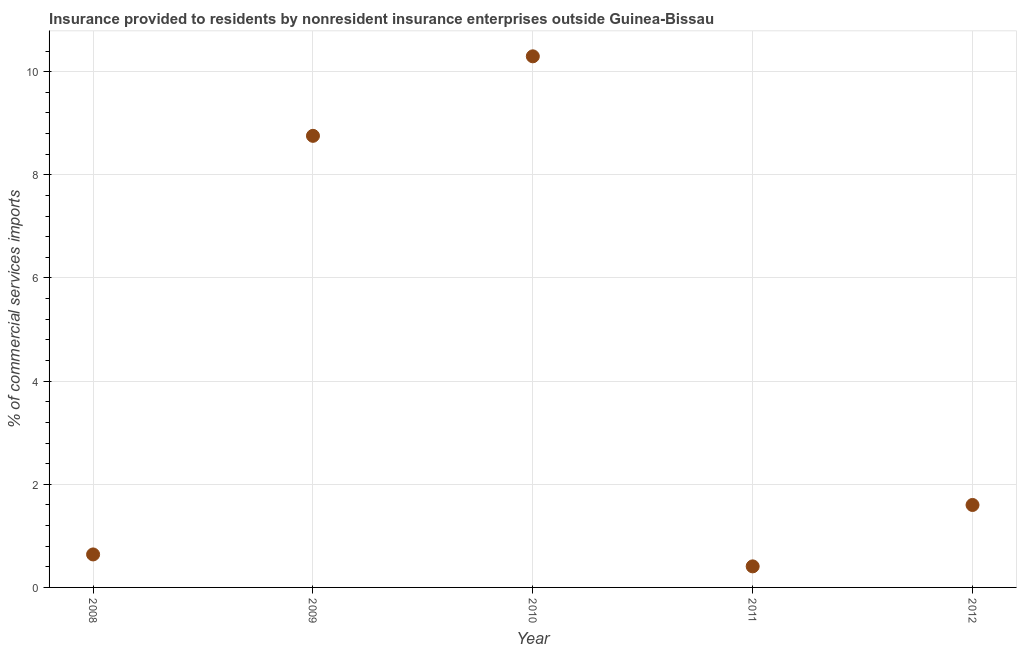What is the insurance provided by non-residents in 2010?
Offer a very short reply. 10.3. Across all years, what is the maximum insurance provided by non-residents?
Offer a terse response. 10.3. Across all years, what is the minimum insurance provided by non-residents?
Keep it short and to the point. 0.41. What is the sum of the insurance provided by non-residents?
Give a very brief answer. 21.7. What is the difference between the insurance provided by non-residents in 2008 and 2009?
Provide a succinct answer. -8.12. What is the average insurance provided by non-residents per year?
Provide a succinct answer. 4.34. What is the median insurance provided by non-residents?
Your answer should be very brief. 1.6. In how many years, is the insurance provided by non-residents greater than 6.4 %?
Your response must be concise. 2. What is the ratio of the insurance provided by non-residents in 2008 to that in 2010?
Keep it short and to the point. 0.06. Is the difference between the insurance provided by non-residents in 2008 and 2010 greater than the difference between any two years?
Keep it short and to the point. No. What is the difference between the highest and the second highest insurance provided by non-residents?
Your response must be concise. 1.54. Is the sum of the insurance provided by non-residents in 2008 and 2010 greater than the maximum insurance provided by non-residents across all years?
Provide a short and direct response. Yes. What is the difference between the highest and the lowest insurance provided by non-residents?
Give a very brief answer. 9.89. Are the values on the major ticks of Y-axis written in scientific E-notation?
Give a very brief answer. No. Does the graph contain grids?
Make the answer very short. Yes. What is the title of the graph?
Give a very brief answer. Insurance provided to residents by nonresident insurance enterprises outside Guinea-Bissau. What is the label or title of the Y-axis?
Make the answer very short. % of commercial services imports. What is the % of commercial services imports in 2008?
Offer a very short reply. 0.64. What is the % of commercial services imports in 2009?
Make the answer very short. 8.76. What is the % of commercial services imports in 2010?
Your answer should be compact. 10.3. What is the % of commercial services imports in 2011?
Offer a very short reply. 0.41. What is the % of commercial services imports in 2012?
Offer a very short reply. 1.6. What is the difference between the % of commercial services imports in 2008 and 2009?
Offer a terse response. -8.12. What is the difference between the % of commercial services imports in 2008 and 2010?
Give a very brief answer. -9.66. What is the difference between the % of commercial services imports in 2008 and 2011?
Keep it short and to the point. 0.23. What is the difference between the % of commercial services imports in 2008 and 2012?
Offer a very short reply. -0.96. What is the difference between the % of commercial services imports in 2009 and 2010?
Your answer should be very brief. -1.54. What is the difference between the % of commercial services imports in 2009 and 2011?
Offer a very short reply. 8.35. What is the difference between the % of commercial services imports in 2009 and 2012?
Offer a very short reply. 7.16. What is the difference between the % of commercial services imports in 2010 and 2011?
Provide a succinct answer. 9.89. What is the difference between the % of commercial services imports in 2010 and 2012?
Offer a very short reply. 8.7. What is the difference between the % of commercial services imports in 2011 and 2012?
Your answer should be very brief. -1.19. What is the ratio of the % of commercial services imports in 2008 to that in 2009?
Give a very brief answer. 0.07. What is the ratio of the % of commercial services imports in 2008 to that in 2010?
Keep it short and to the point. 0.06. What is the ratio of the % of commercial services imports in 2008 to that in 2011?
Give a very brief answer. 1.57. What is the ratio of the % of commercial services imports in 2008 to that in 2012?
Your answer should be very brief. 0.4. What is the ratio of the % of commercial services imports in 2009 to that in 2011?
Provide a succinct answer. 21.45. What is the ratio of the % of commercial services imports in 2009 to that in 2012?
Make the answer very short. 5.48. What is the ratio of the % of commercial services imports in 2010 to that in 2011?
Provide a succinct answer. 25.23. What is the ratio of the % of commercial services imports in 2010 to that in 2012?
Your answer should be very brief. 6.44. What is the ratio of the % of commercial services imports in 2011 to that in 2012?
Give a very brief answer. 0.26. 